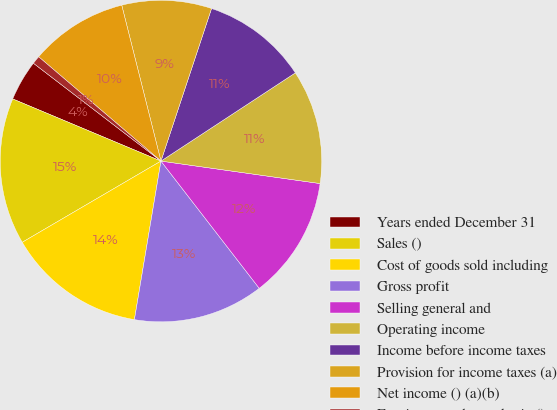<chart> <loc_0><loc_0><loc_500><loc_500><pie_chart><fcel>Years ended December 31<fcel>Sales ()<fcel>Cost of goods sold including<fcel>Gross profit<fcel>Selling general and<fcel>Operating income<fcel>Income before income taxes<fcel>Provision for income taxes (a)<fcel>Net income () (a)(b)<fcel>Earnings per share - basic ()<nl><fcel>4.1%<fcel>14.75%<fcel>13.93%<fcel>13.11%<fcel>12.3%<fcel>11.48%<fcel>10.66%<fcel>9.02%<fcel>9.84%<fcel>0.82%<nl></chart> 